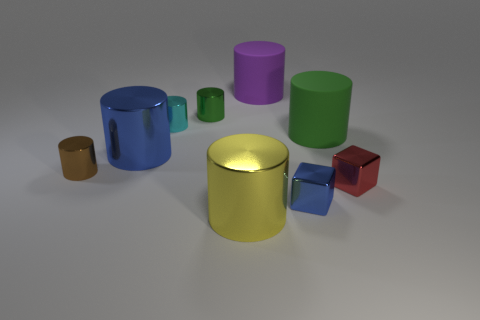Is there a large green cylinder that has the same material as the small brown cylinder?
Provide a short and direct response. No. How many objects are either large things that are to the left of the green rubber thing or tiny things on the left side of the small green thing?
Provide a succinct answer. 5. Is the shape of the large purple matte object the same as the cyan thing that is on the left side of the green matte cylinder?
Your response must be concise. Yes. How many other things are the same shape as the small cyan thing?
Offer a terse response. 6. How many objects are small green matte objects or tiny green cylinders?
Offer a terse response. 1. Is there any other thing that has the same size as the yellow shiny cylinder?
Give a very brief answer. Yes. The red metallic object behind the blue metallic object that is right of the small green object is what shape?
Keep it short and to the point. Cube. Are there fewer large blue cylinders than big gray metallic things?
Your answer should be compact. No. There is a thing that is both in front of the small brown metallic cylinder and on the left side of the purple matte cylinder; what is its size?
Your answer should be compact. Large. Do the green metal thing and the yellow shiny cylinder have the same size?
Your answer should be compact. No. 